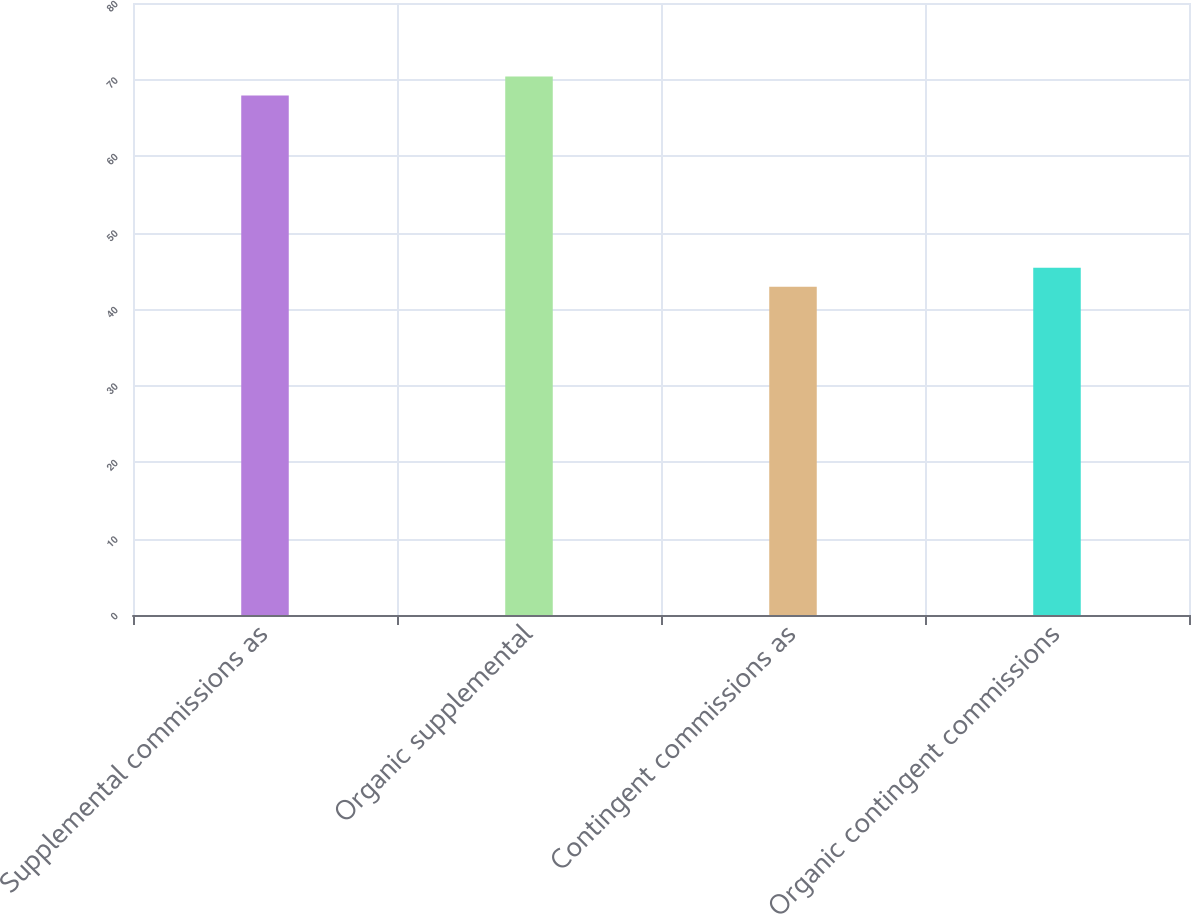<chart> <loc_0><loc_0><loc_500><loc_500><bar_chart><fcel>Supplemental commissions as<fcel>Organic supplemental<fcel>Contingent commissions as<fcel>Organic contingent commissions<nl><fcel>67.9<fcel>70.4<fcel>42.9<fcel>45.4<nl></chart> 